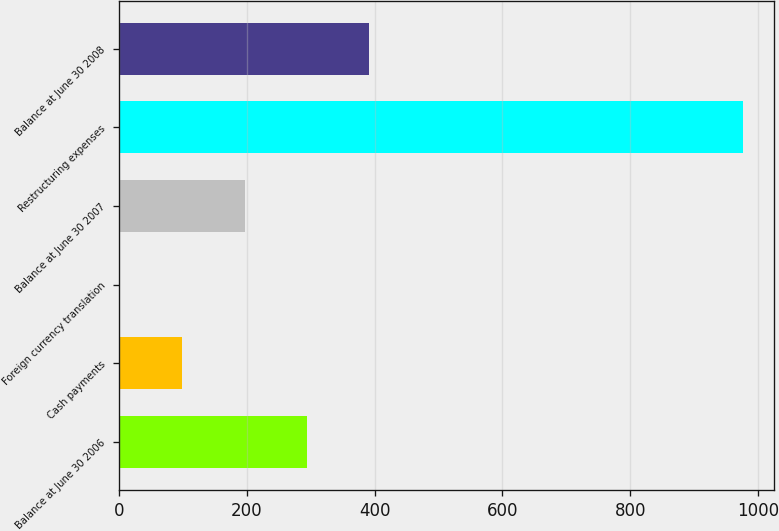Convert chart. <chart><loc_0><loc_0><loc_500><loc_500><bar_chart><fcel>Balance at June 30 2006<fcel>Cash payments<fcel>Foreign currency translation<fcel>Balance at June 30 2007<fcel>Restructuring expenses<fcel>Balance at June 30 2008<nl><fcel>294.2<fcel>99.4<fcel>2<fcel>196.8<fcel>976<fcel>391.6<nl></chart> 